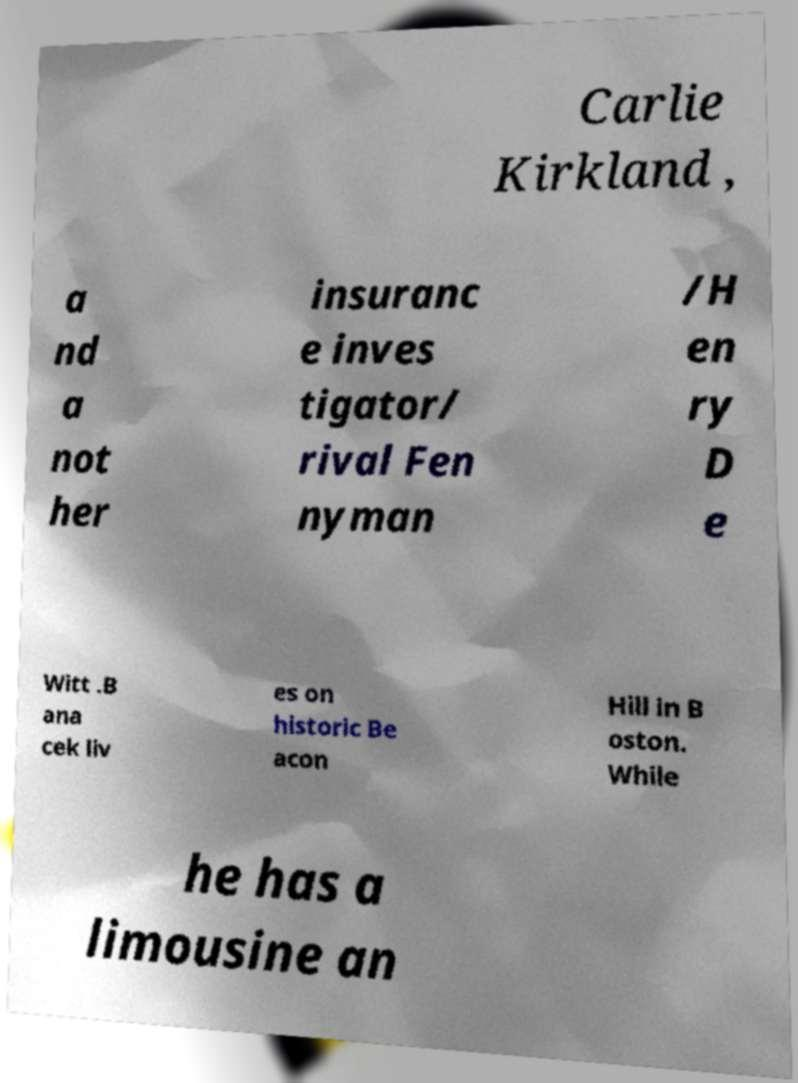Can you read and provide the text displayed in the image?This photo seems to have some interesting text. Can you extract and type it out for me? Carlie Kirkland , a nd a not her insuranc e inves tigator/ rival Fen nyman /H en ry D e Witt .B ana cek liv es on historic Be acon Hill in B oston. While he has a limousine an 